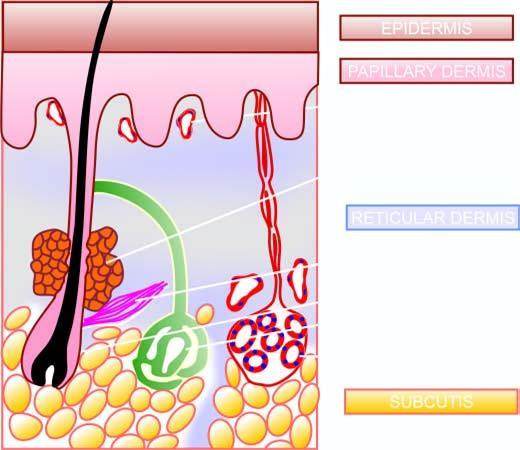s main structures identified in a section of the normal skin?
Answer the question using a single word or phrase. Yes 